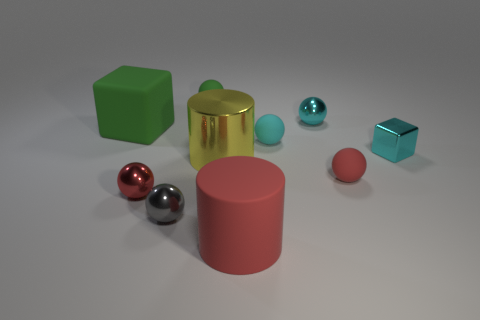There is a cyan thing that is the same shape as the big green thing; what size is it?
Make the answer very short. Small. Is the shape of the gray thing the same as the small green matte thing?
Your answer should be compact. Yes. There is another big shiny thing that is the same shape as the big red object; what color is it?
Keep it short and to the point. Yellow. What number of balls have the same color as the matte cylinder?
Keep it short and to the point. 2. How many things are either rubber objects that are behind the large green rubber block or cyan matte balls?
Make the answer very short. 2. There is a green matte object that is on the left side of the small green thing; how big is it?
Provide a succinct answer. Large. Is the number of yellow metal cylinders less than the number of big purple matte spheres?
Provide a succinct answer. No. Is the material of the ball on the right side of the cyan metal sphere the same as the block to the right of the gray metallic sphere?
Give a very brief answer. No. There is a small red object that is on the right side of the rubber thing in front of the small red sphere on the left side of the yellow cylinder; what is its shape?
Keep it short and to the point. Sphere. What number of balls are the same material as the green block?
Provide a succinct answer. 3. 